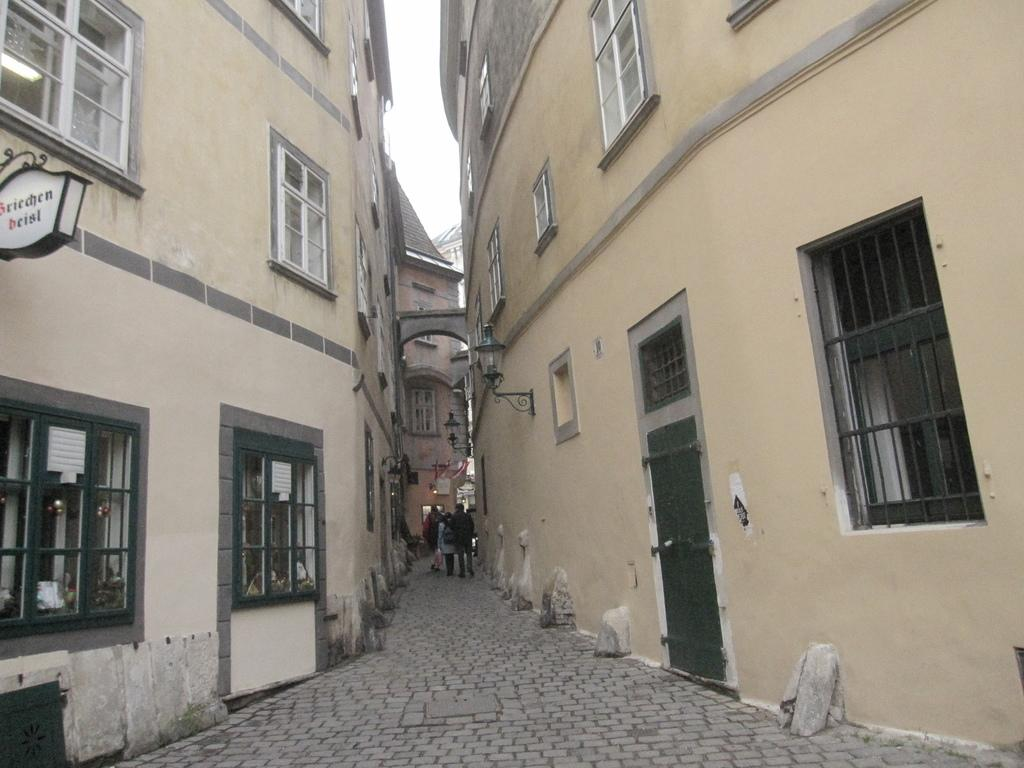What type of structures can be seen in the image? There are buildings in the image. What are the people in the image doing? The people in the image are walking. How would you describe the weather based on the image? The sky is cloudy in the image. Can you identify any specific features of the buildings? There is a name board fixed to a wall in the image, and there are windows visible in the image. What type of frame surrounds the buildings in the image? There is no frame surrounding the buildings in the image; they are not enclosed within a frame. 